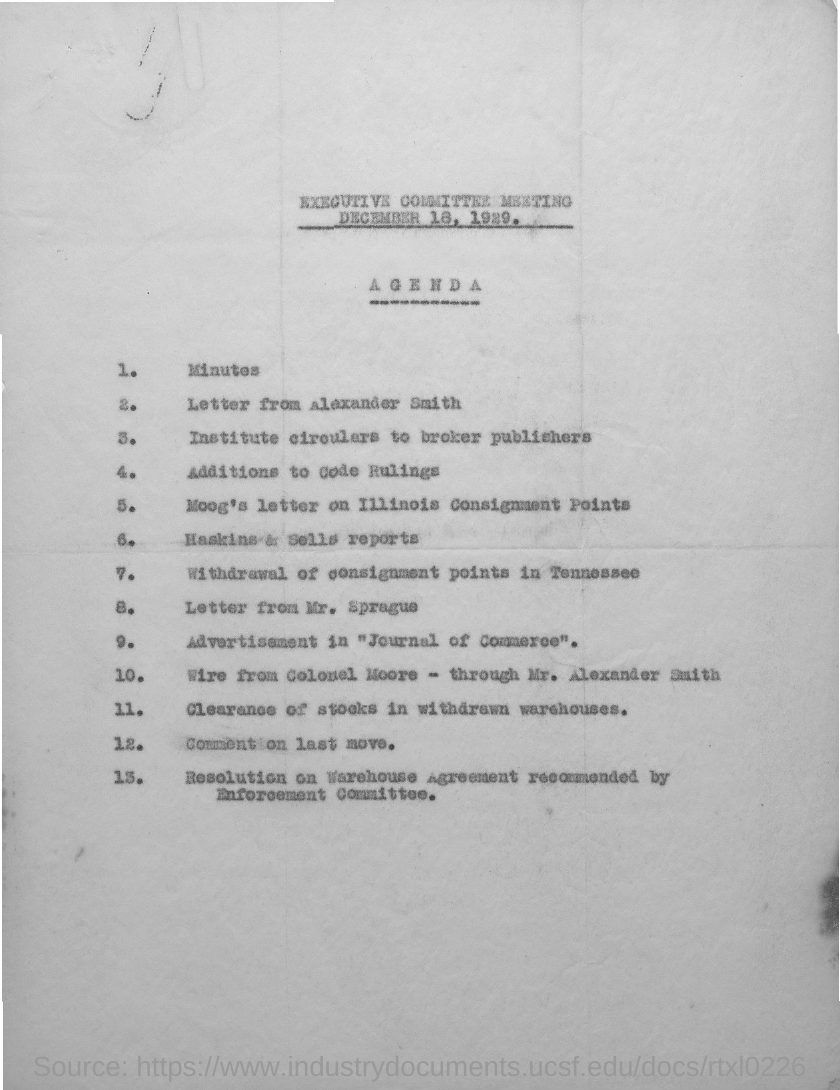What is the Agenda number 1?
Make the answer very short. Minutes. 